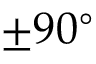Convert formula to latex. <formula><loc_0><loc_0><loc_500><loc_500>\pm 9 0 ^ { \circ }</formula> 